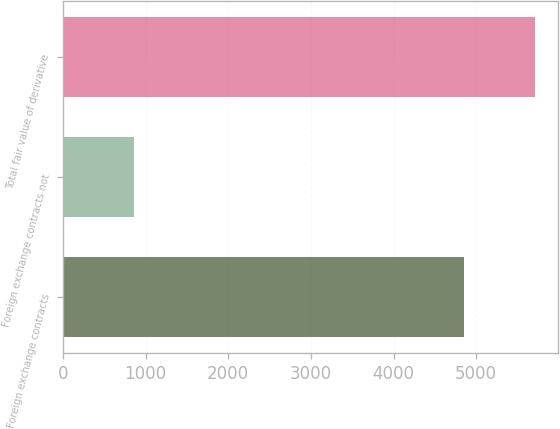Convert chart. <chart><loc_0><loc_0><loc_500><loc_500><bar_chart><fcel>Foreign exchange contracts<fcel>Foreign exchange contracts not<fcel>Total fair value of derivative<nl><fcel>4848<fcel>862<fcel>5710<nl></chart> 